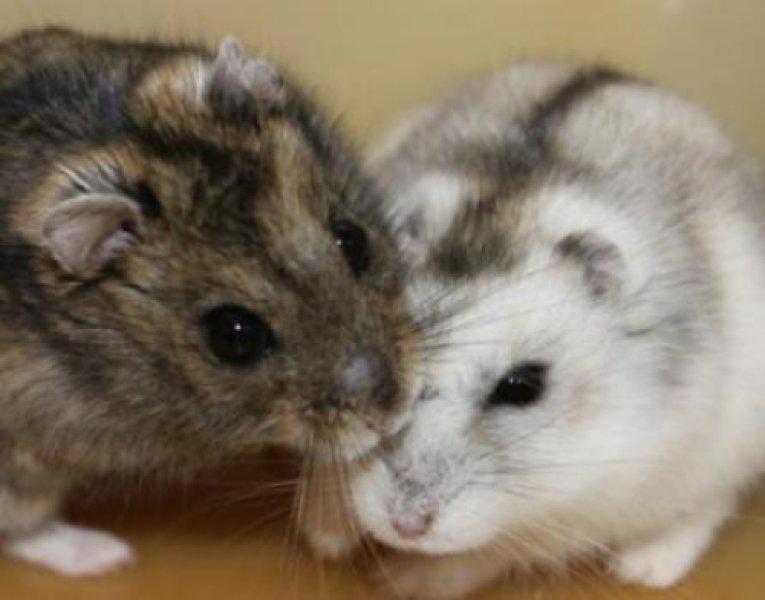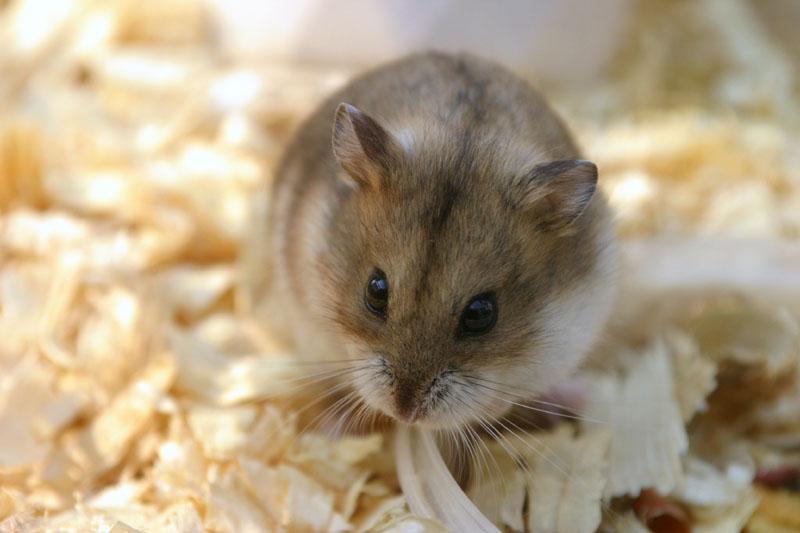The first image is the image on the left, the second image is the image on the right. Evaluate the accuracy of this statement regarding the images: "Each image contains one pet rodent, with one on fabric and one on shredded bedding.". Is it true? Answer yes or no. No. The first image is the image on the left, the second image is the image on the right. Examine the images to the left and right. Is the description "In the image to the left, there is a hamster who happens to have at least half of their fur white in color." accurate? Answer yes or no. Yes. 